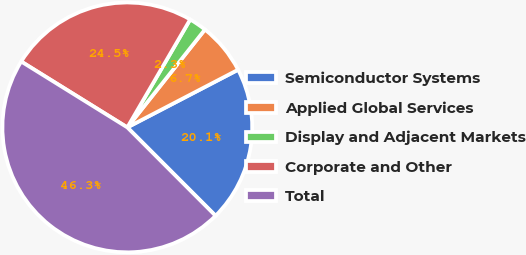<chart> <loc_0><loc_0><loc_500><loc_500><pie_chart><fcel>Semiconductor Systems<fcel>Applied Global Services<fcel>Display and Adjacent Markets<fcel>Corporate and Other<fcel>Total<nl><fcel>20.15%<fcel>6.69%<fcel>2.28%<fcel>24.55%<fcel>46.33%<nl></chart> 